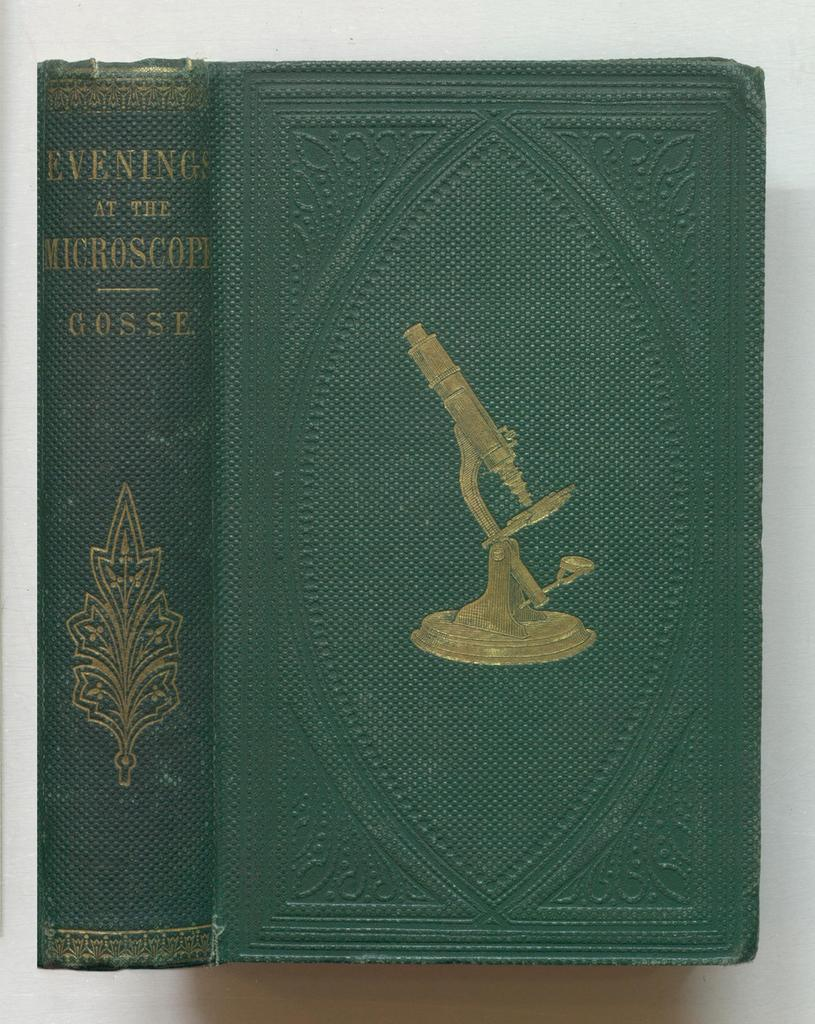<image>
Offer a succinct explanation of the picture presented. An antique book by Gosse is called Evenings at the Microscope 